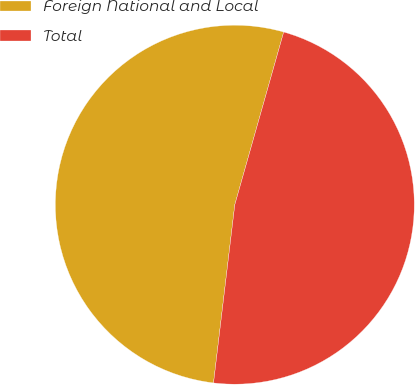Convert chart. <chart><loc_0><loc_0><loc_500><loc_500><pie_chart><fcel>Foreign National and Local<fcel>Total<nl><fcel>52.5%<fcel>47.5%<nl></chart> 